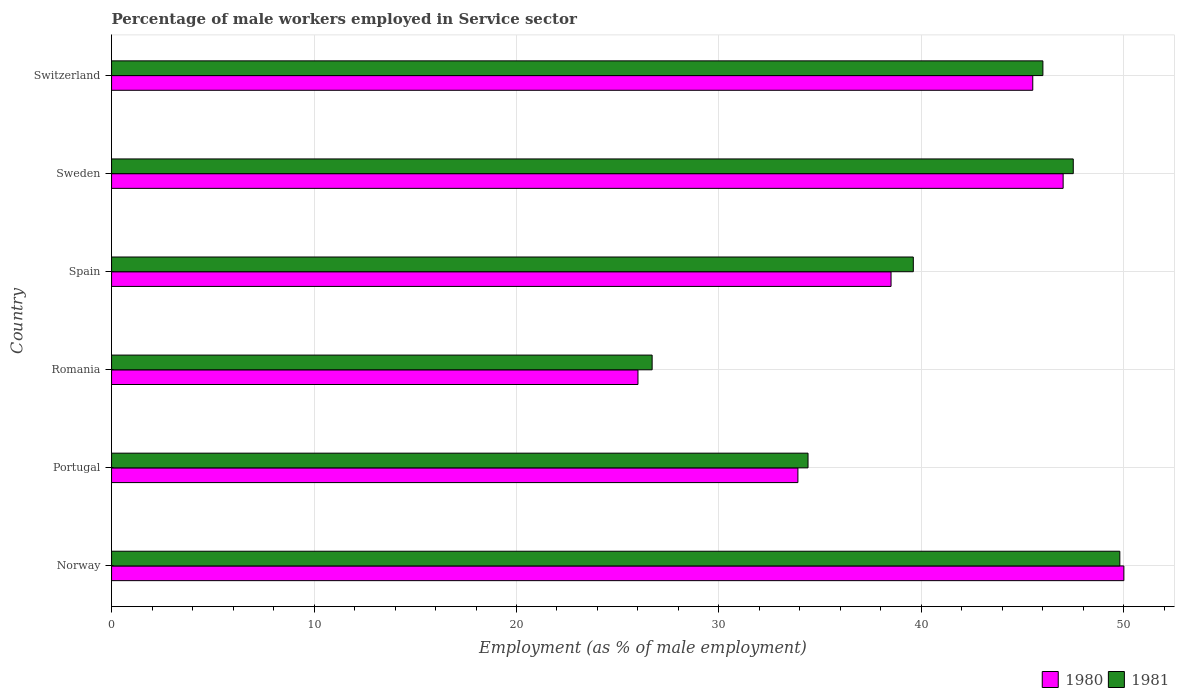How many different coloured bars are there?
Offer a terse response. 2. How many bars are there on the 3rd tick from the bottom?
Provide a short and direct response. 2. What is the label of the 4th group of bars from the top?
Your answer should be compact. Romania. In how many cases, is the number of bars for a given country not equal to the number of legend labels?
Provide a succinct answer. 0. What is the percentage of male workers employed in Service sector in 1980 in Sweden?
Your response must be concise. 47. Across all countries, what is the minimum percentage of male workers employed in Service sector in 1981?
Your answer should be compact. 26.7. In which country was the percentage of male workers employed in Service sector in 1980 maximum?
Your answer should be compact. Norway. In which country was the percentage of male workers employed in Service sector in 1981 minimum?
Your response must be concise. Romania. What is the total percentage of male workers employed in Service sector in 1980 in the graph?
Offer a very short reply. 240.9. What is the difference between the percentage of male workers employed in Service sector in 1981 in Norway and that in Sweden?
Provide a short and direct response. 2.3. What is the difference between the percentage of male workers employed in Service sector in 1981 in Spain and the percentage of male workers employed in Service sector in 1980 in Portugal?
Offer a very short reply. 5.7. What is the average percentage of male workers employed in Service sector in 1980 per country?
Keep it short and to the point. 40.15. What is the difference between the percentage of male workers employed in Service sector in 1981 and percentage of male workers employed in Service sector in 1980 in Sweden?
Your response must be concise. 0.5. In how many countries, is the percentage of male workers employed in Service sector in 1981 greater than 2 %?
Offer a terse response. 6. What is the ratio of the percentage of male workers employed in Service sector in 1981 in Romania to that in Sweden?
Your response must be concise. 0.56. Is the percentage of male workers employed in Service sector in 1981 in Sweden less than that in Switzerland?
Offer a terse response. No. What is the difference between the highest and the second highest percentage of male workers employed in Service sector in 1981?
Make the answer very short. 2.3. What is the difference between the highest and the lowest percentage of male workers employed in Service sector in 1980?
Provide a short and direct response. 24. What does the 1st bar from the bottom in Spain represents?
Keep it short and to the point. 1980. How many bars are there?
Ensure brevity in your answer.  12. How many countries are there in the graph?
Your response must be concise. 6. How many legend labels are there?
Provide a short and direct response. 2. What is the title of the graph?
Your answer should be compact. Percentage of male workers employed in Service sector. Does "2013" appear as one of the legend labels in the graph?
Your answer should be very brief. No. What is the label or title of the X-axis?
Give a very brief answer. Employment (as % of male employment). What is the label or title of the Y-axis?
Ensure brevity in your answer.  Country. What is the Employment (as % of male employment) of 1980 in Norway?
Ensure brevity in your answer.  50. What is the Employment (as % of male employment) of 1981 in Norway?
Your answer should be compact. 49.8. What is the Employment (as % of male employment) in 1980 in Portugal?
Your response must be concise. 33.9. What is the Employment (as % of male employment) in 1981 in Portugal?
Offer a very short reply. 34.4. What is the Employment (as % of male employment) in 1981 in Romania?
Offer a terse response. 26.7. What is the Employment (as % of male employment) in 1980 in Spain?
Your answer should be compact. 38.5. What is the Employment (as % of male employment) of 1981 in Spain?
Your answer should be compact. 39.6. What is the Employment (as % of male employment) of 1981 in Sweden?
Provide a succinct answer. 47.5. What is the Employment (as % of male employment) of 1980 in Switzerland?
Make the answer very short. 45.5. What is the Employment (as % of male employment) in 1981 in Switzerland?
Provide a short and direct response. 46. Across all countries, what is the maximum Employment (as % of male employment) in 1981?
Offer a very short reply. 49.8. Across all countries, what is the minimum Employment (as % of male employment) of 1981?
Keep it short and to the point. 26.7. What is the total Employment (as % of male employment) in 1980 in the graph?
Keep it short and to the point. 240.9. What is the total Employment (as % of male employment) in 1981 in the graph?
Ensure brevity in your answer.  244. What is the difference between the Employment (as % of male employment) in 1980 in Norway and that in Portugal?
Give a very brief answer. 16.1. What is the difference between the Employment (as % of male employment) in 1981 in Norway and that in Portugal?
Keep it short and to the point. 15.4. What is the difference between the Employment (as % of male employment) of 1980 in Norway and that in Romania?
Ensure brevity in your answer.  24. What is the difference between the Employment (as % of male employment) of 1981 in Norway and that in Romania?
Offer a terse response. 23.1. What is the difference between the Employment (as % of male employment) of 1980 in Norway and that in Spain?
Your answer should be compact. 11.5. What is the difference between the Employment (as % of male employment) of 1980 in Norway and that in Sweden?
Provide a succinct answer. 3. What is the difference between the Employment (as % of male employment) in 1981 in Norway and that in Sweden?
Provide a short and direct response. 2.3. What is the difference between the Employment (as % of male employment) of 1981 in Norway and that in Switzerland?
Offer a terse response. 3.8. What is the difference between the Employment (as % of male employment) in 1981 in Portugal and that in Spain?
Your answer should be very brief. -5.2. What is the difference between the Employment (as % of male employment) of 1981 in Portugal and that in Sweden?
Ensure brevity in your answer.  -13.1. What is the difference between the Employment (as % of male employment) of 1980 in Portugal and that in Switzerland?
Ensure brevity in your answer.  -11.6. What is the difference between the Employment (as % of male employment) in 1981 in Portugal and that in Switzerland?
Provide a short and direct response. -11.6. What is the difference between the Employment (as % of male employment) in 1981 in Romania and that in Spain?
Your answer should be very brief. -12.9. What is the difference between the Employment (as % of male employment) in 1981 in Romania and that in Sweden?
Offer a very short reply. -20.8. What is the difference between the Employment (as % of male employment) of 1980 in Romania and that in Switzerland?
Your response must be concise. -19.5. What is the difference between the Employment (as % of male employment) in 1981 in Romania and that in Switzerland?
Offer a very short reply. -19.3. What is the difference between the Employment (as % of male employment) of 1980 in Spain and that in Sweden?
Provide a short and direct response. -8.5. What is the difference between the Employment (as % of male employment) of 1981 in Spain and that in Sweden?
Offer a very short reply. -7.9. What is the difference between the Employment (as % of male employment) in 1980 in Spain and that in Switzerland?
Provide a short and direct response. -7. What is the difference between the Employment (as % of male employment) of 1980 in Sweden and that in Switzerland?
Keep it short and to the point. 1.5. What is the difference between the Employment (as % of male employment) of 1980 in Norway and the Employment (as % of male employment) of 1981 in Romania?
Make the answer very short. 23.3. What is the difference between the Employment (as % of male employment) in 1980 in Norway and the Employment (as % of male employment) in 1981 in Sweden?
Offer a terse response. 2.5. What is the difference between the Employment (as % of male employment) in 1980 in Portugal and the Employment (as % of male employment) in 1981 in Romania?
Your answer should be compact. 7.2. What is the difference between the Employment (as % of male employment) in 1980 in Portugal and the Employment (as % of male employment) in 1981 in Sweden?
Your answer should be compact. -13.6. What is the difference between the Employment (as % of male employment) of 1980 in Portugal and the Employment (as % of male employment) of 1981 in Switzerland?
Provide a succinct answer. -12.1. What is the difference between the Employment (as % of male employment) of 1980 in Romania and the Employment (as % of male employment) of 1981 in Sweden?
Your answer should be compact. -21.5. What is the difference between the Employment (as % of male employment) of 1980 in Spain and the Employment (as % of male employment) of 1981 in Sweden?
Offer a terse response. -9. What is the difference between the Employment (as % of male employment) of 1980 in Spain and the Employment (as % of male employment) of 1981 in Switzerland?
Keep it short and to the point. -7.5. What is the difference between the Employment (as % of male employment) of 1980 in Sweden and the Employment (as % of male employment) of 1981 in Switzerland?
Your response must be concise. 1. What is the average Employment (as % of male employment) in 1980 per country?
Make the answer very short. 40.15. What is the average Employment (as % of male employment) in 1981 per country?
Give a very brief answer. 40.67. What is the difference between the Employment (as % of male employment) in 1980 and Employment (as % of male employment) in 1981 in Norway?
Make the answer very short. 0.2. What is the difference between the Employment (as % of male employment) of 1980 and Employment (as % of male employment) of 1981 in Portugal?
Your answer should be compact. -0.5. What is the difference between the Employment (as % of male employment) of 1980 and Employment (as % of male employment) of 1981 in Romania?
Provide a short and direct response. -0.7. What is the difference between the Employment (as % of male employment) in 1980 and Employment (as % of male employment) in 1981 in Sweden?
Keep it short and to the point. -0.5. What is the difference between the Employment (as % of male employment) in 1980 and Employment (as % of male employment) in 1981 in Switzerland?
Make the answer very short. -0.5. What is the ratio of the Employment (as % of male employment) in 1980 in Norway to that in Portugal?
Offer a very short reply. 1.47. What is the ratio of the Employment (as % of male employment) of 1981 in Norway to that in Portugal?
Provide a succinct answer. 1.45. What is the ratio of the Employment (as % of male employment) in 1980 in Norway to that in Romania?
Your answer should be very brief. 1.92. What is the ratio of the Employment (as % of male employment) of 1981 in Norway to that in Romania?
Offer a terse response. 1.87. What is the ratio of the Employment (as % of male employment) of 1980 in Norway to that in Spain?
Keep it short and to the point. 1.3. What is the ratio of the Employment (as % of male employment) in 1981 in Norway to that in Spain?
Your response must be concise. 1.26. What is the ratio of the Employment (as % of male employment) in 1980 in Norway to that in Sweden?
Provide a short and direct response. 1.06. What is the ratio of the Employment (as % of male employment) in 1981 in Norway to that in Sweden?
Make the answer very short. 1.05. What is the ratio of the Employment (as % of male employment) in 1980 in Norway to that in Switzerland?
Your answer should be very brief. 1.1. What is the ratio of the Employment (as % of male employment) in 1981 in Norway to that in Switzerland?
Your answer should be very brief. 1.08. What is the ratio of the Employment (as % of male employment) of 1980 in Portugal to that in Romania?
Ensure brevity in your answer.  1.3. What is the ratio of the Employment (as % of male employment) of 1981 in Portugal to that in Romania?
Ensure brevity in your answer.  1.29. What is the ratio of the Employment (as % of male employment) of 1980 in Portugal to that in Spain?
Offer a very short reply. 0.88. What is the ratio of the Employment (as % of male employment) in 1981 in Portugal to that in Spain?
Make the answer very short. 0.87. What is the ratio of the Employment (as % of male employment) in 1980 in Portugal to that in Sweden?
Keep it short and to the point. 0.72. What is the ratio of the Employment (as % of male employment) in 1981 in Portugal to that in Sweden?
Offer a very short reply. 0.72. What is the ratio of the Employment (as % of male employment) in 1980 in Portugal to that in Switzerland?
Provide a short and direct response. 0.75. What is the ratio of the Employment (as % of male employment) of 1981 in Portugal to that in Switzerland?
Make the answer very short. 0.75. What is the ratio of the Employment (as % of male employment) of 1980 in Romania to that in Spain?
Give a very brief answer. 0.68. What is the ratio of the Employment (as % of male employment) in 1981 in Romania to that in Spain?
Offer a very short reply. 0.67. What is the ratio of the Employment (as % of male employment) in 1980 in Romania to that in Sweden?
Offer a very short reply. 0.55. What is the ratio of the Employment (as % of male employment) of 1981 in Romania to that in Sweden?
Your answer should be very brief. 0.56. What is the ratio of the Employment (as % of male employment) of 1980 in Romania to that in Switzerland?
Make the answer very short. 0.57. What is the ratio of the Employment (as % of male employment) of 1981 in Romania to that in Switzerland?
Your response must be concise. 0.58. What is the ratio of the Employment (as % of male employment) in 1980 in Spain to that in Sweden?
Your answer should be compact. 0.82. What is the ratio of the Employment (as % of male employment) of 1981 in Spain to that in Sweden?
Keep it short and to the point. 0.83. What is the ratio of the Employment (as % of male employment) in 1980 in Spain to that in Switzerland?
Provide a short and direct response. 0.85. What is the ratio of the Employment (as % of male employment) of 1981 in Spain to that in Switzerland?
Offer a very short reply. 0.86. What is the ratio of the Employment (as % of male employment) of 1980 in Sweden to that in Switzerland?
Your answer should be very brief. 1.03. What is the ratio of the Employment (as % of male employment) in 1981 in Sweden to that in Switzerland?
Your response must be concise. 1.03. What is the difference between the highest and the lowest Employment (as % of male employment) of 1980?
Provide a short and direct response. 24. What is the difference between the highest and the lowest Employment (as % of male employment) of 1981?
Keep it short and to the point. 23.1. 